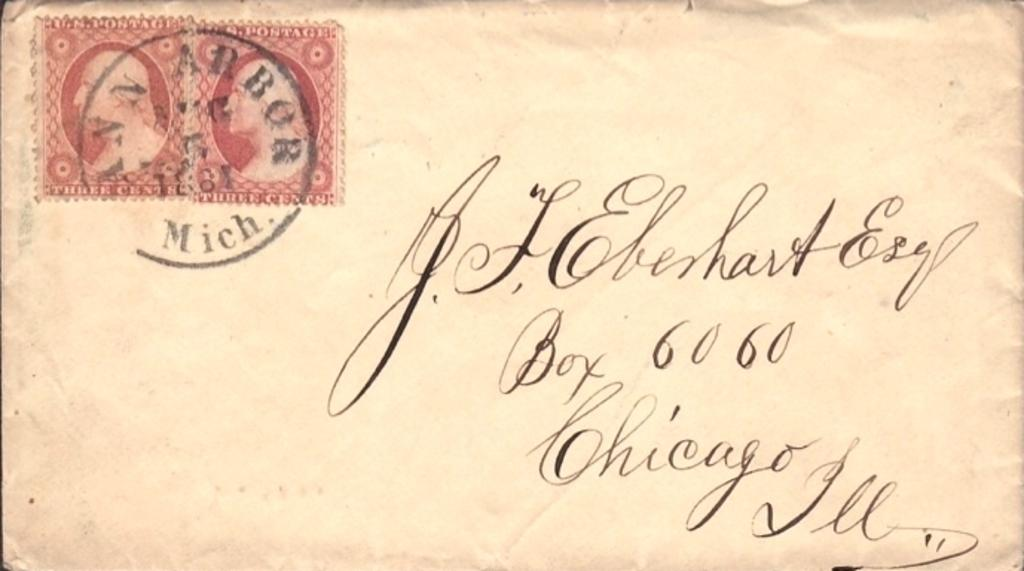<image>
Give a short and clear explanation of the subsequent image. An envelope with a red stamp in the top left corner and post marked from Ann Arbor, Michigan. 